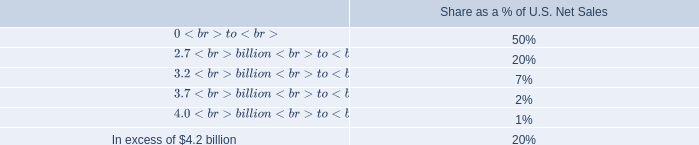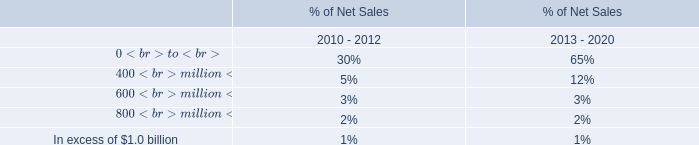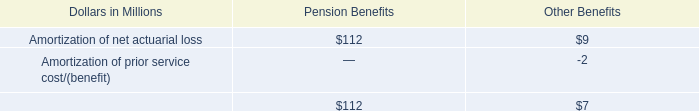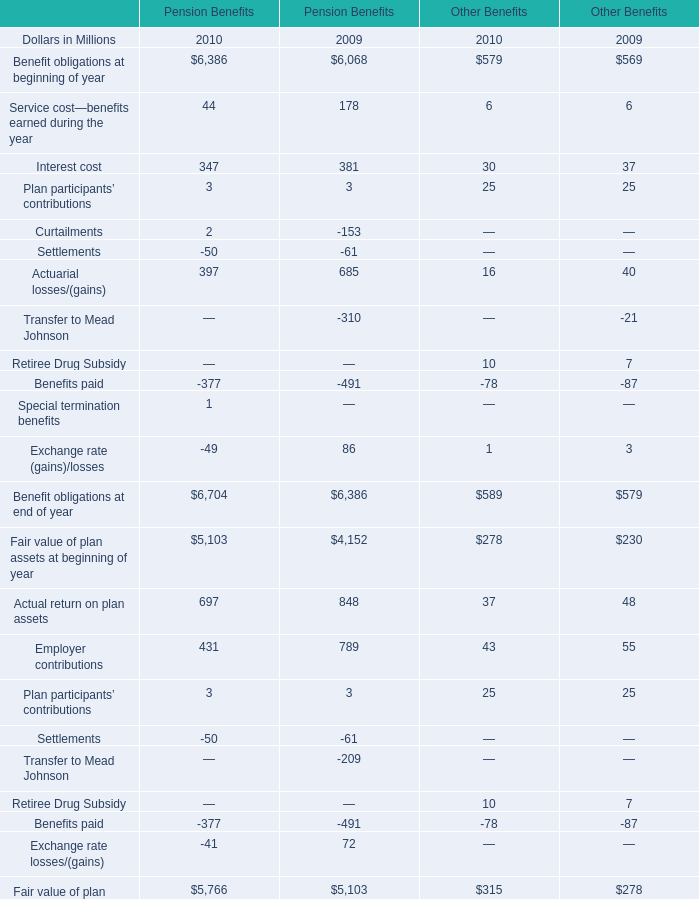what is the highest total amount of Benefit obligations at beginning of year? (in million) 
Answer: 6386. 